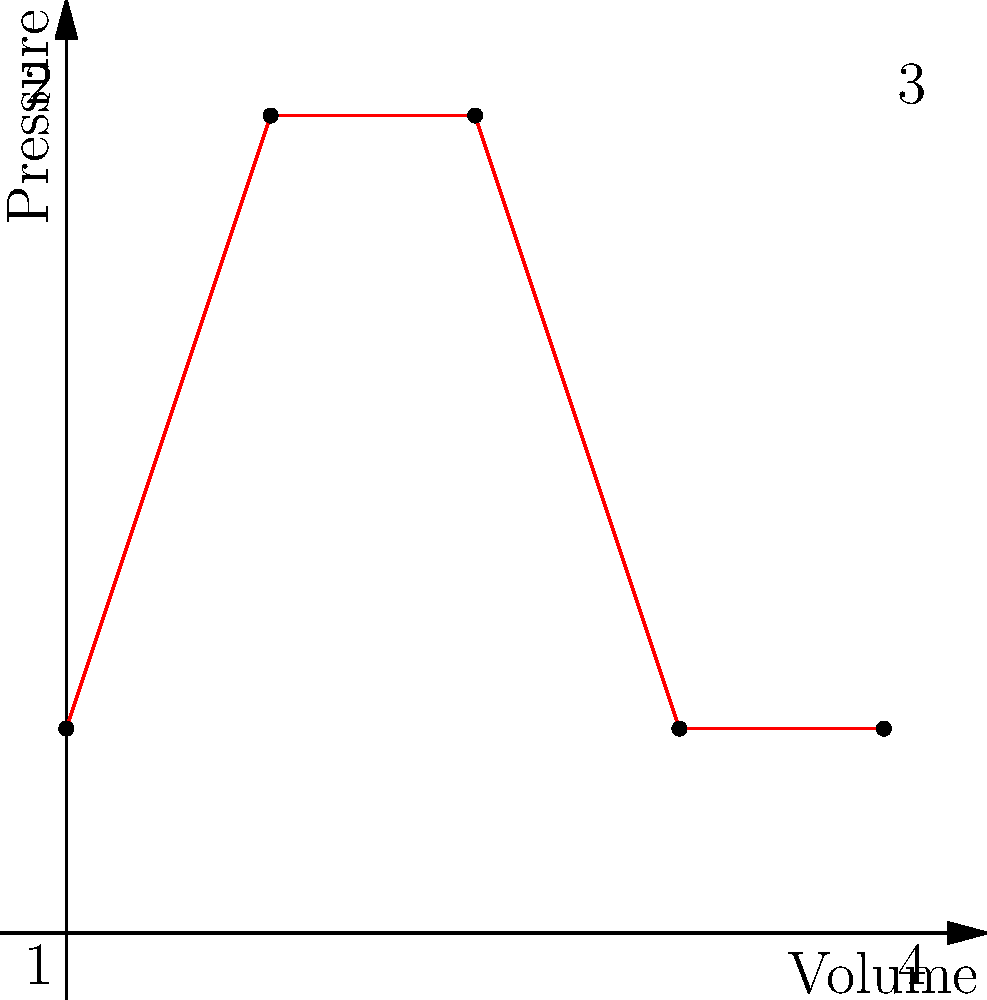As a comic book enthusiast who appreciates visual storytelling, imagine this pressure-volume diagram represents the four-stroke cycle of an engine in a futuristic vehicle from your favorite sci-fi series. Which stroke of the cycle represents the power stroke, where the engine produces the most energy? To answer this question, let's break down the four-stroke cycle as represented in the pressure-volume diagram:

1. The cycle starts at point 1 and moves to point 2. This represents the compression stroke, where the piston moves upward, compressing the air-fuel mixture.

2. From point 2 to point 3, we see a horizontal line at constant volume. This represents the ignition of the fuel mixture.

3. The line from point 3 to point 4 represents the power stroke. This is where the expanding gases from combustion push the piston down, increasing the volume while decreasing the pressure.

4. Finally, the line from point 4 back to point 1 represents the exhaust stroke, where the piston moves up again to expel the spent gases.

The power stroke is the part of the cycle where the engine produces the most energy. This is represented by the line from point 3 to point 4, where the high-pressure gases expand, pushing the piston down and increasing the volume.

In the context of a comic book, you could imagine this as the moment when the hero's vehicle suddenly surges forward with a burst of power, perhaps escaping from a villain or racing towards their destination.
Answer: 3 to 4 